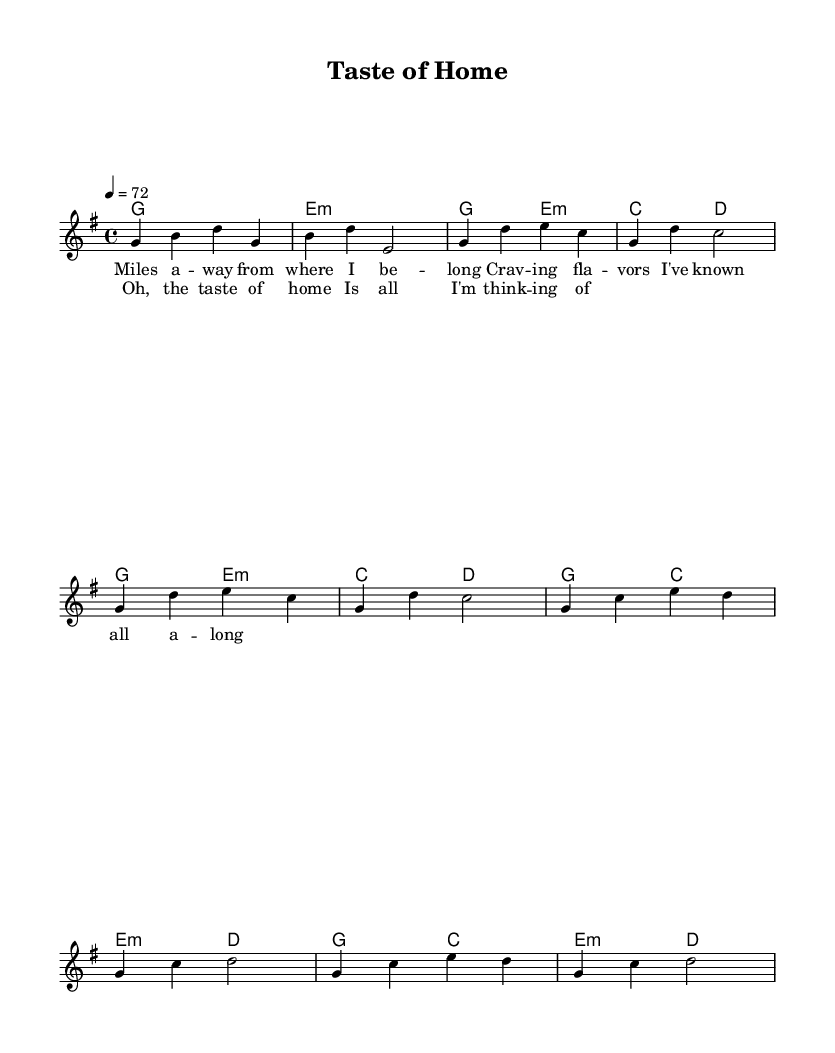What is the key signature of this music? The key signature is G major, which has one sharp (F#). This can be determined by looking at the key indicated at the beginning of the score, following the global declaration.
Answer: G major What is the time signature of this music? The time signature is 4/4, as indicated at the beginning of the score. In this case, the numbers signify four beats per measure and the quarter note receives one beat.
Answer: 4/4 What is the tempo marking in this music? The tempo marking is 72 beats per minute, specified in the global declaration. This indicates that there are 72 beats in one minute, guiding the speed at which the piece should be played.
Answer: 72 How many measures are in the chorus section? The chorus section consists of four measures, which can be identified by counting the bars between the lyrics "Oh, the taste of home" and "Is all I'm think -- ing of."
Answer: 4 What is the first note of the melody? The first note of the melody is G. This is found at the start of the melody line provided after the global declaration, where the musical pitches begin.
Answer: G What chords are played in the intro? The chords played in the intro are G major followed by E minor. This can be found in the harmonies section under the chordmode where the first two measures are specified.
Answer: G major, E minor 